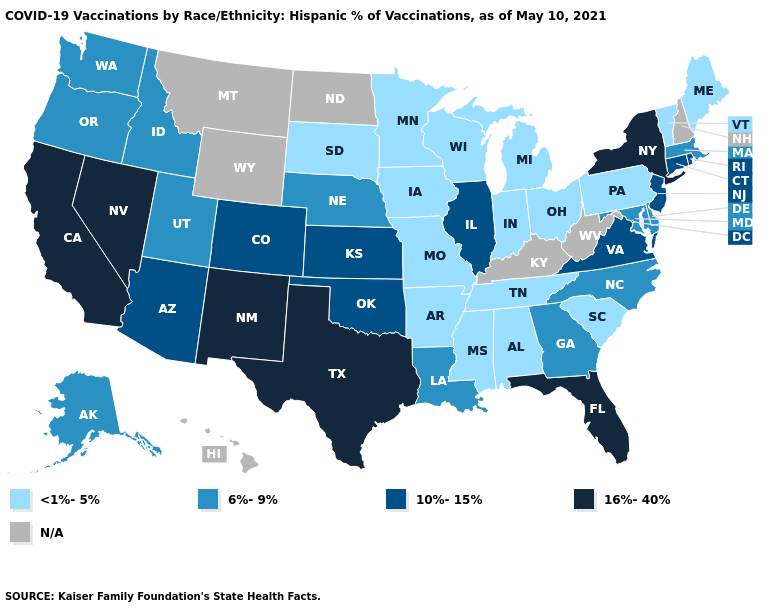Name the states that have a value in the range 6%-9%?
Keep it brief. Alaska, Delaware, Georgia, Idaho, Louisiana, Maryland, Massachusetts, Nebraska, North Carolina, Oregon, Utah, Washington. What is the value of Arizona?
Concise answer only. 10%-15%. Name the states that have a value in the range 6%-9%?
Concise answer only. Alaska, Delaware, Georgia, Idaho, Louisiana, Maryland, Massachusetts, Nebraska, North Carolina, Oregon, Utah, Washington. Which states have the lowest value in the Northeast?
Write a very short answer. Maine, Pennsylvania, Vermont. What is the lowest value in the USA?
Short answer required. <1%-5%. Name the states that have a value in the range <1%-5%?
Short answer required. Alabama, Arkansas, Indiana, Iowa, Maine, Michigan, Minnesota, Mississippi, Missouri, Ohio, Pennsylvania, South Carolina, South Dakota, Tennessee, Vermont, Wisconsin. Among the states that border Montana , which have the lowest value?
Quick response, please. South Dakota. Name the states that have a value in the range 6%-9%?
Write a very short answer. Alaska, Delaware, Georgia, Idaho, Louisiana, Maryland, Massachusetts, Nebraska, North Carolina, Oregon, Utah, Washington. What is the value of New York?
Answer briefly. 16%-40%. Does the map have missing data?
Quick response, please. Yes. Name the states that have a value in the range 6%-9%?
Quick response, please. Alaska, Delaware, Georgia, Idaho, Louisiana, Maryland, Massachusetts, Nebraska, North Carolina, Oregon, Utah, Washington. What is the highest value in the USA?
Answer briefly. 16%-40%. What is the value of Wisconsin?
Be succinct. <1%-5%. What is the highest value in the West ?
Keep it brief. 16%-40%. What is the value of Rhode Island?
Write a very short answer. 10%-15%. 